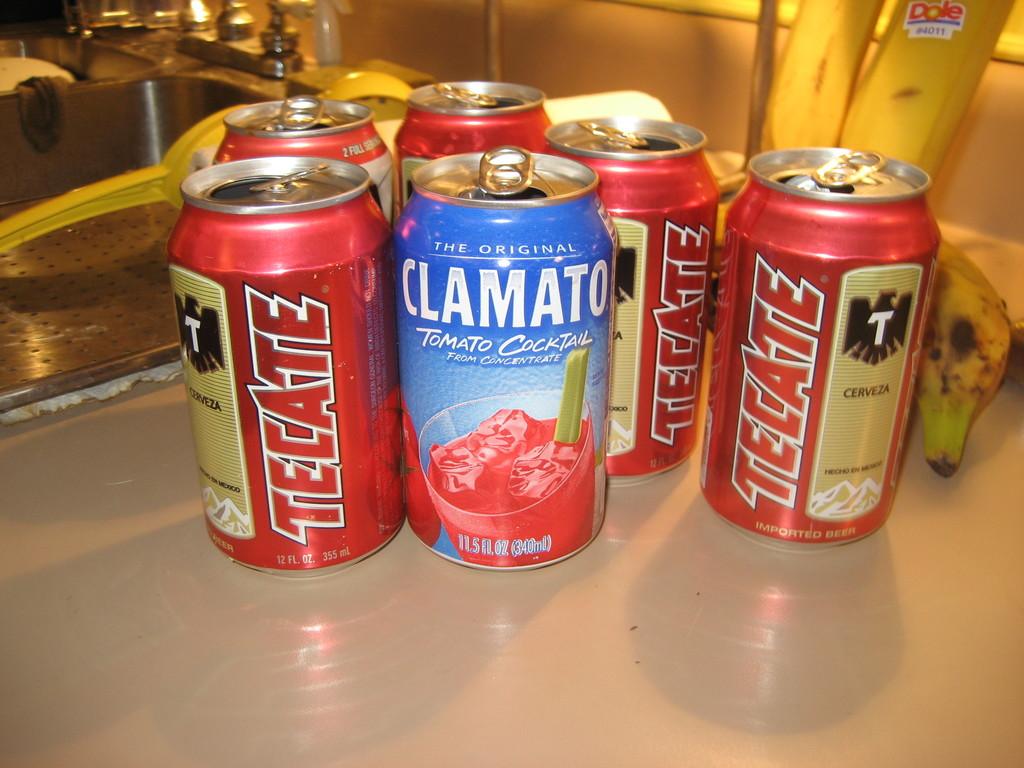What brand of beer is in the red cans?
Your answer should be compact. Tecate. What kind of cocktail does clamato make?
Your response must be concise. Tomato. 